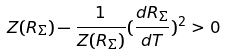<formula> <loc_0><loc_0><loc_500><loc_500>Z ( R _ { \Sigma } ) - \frac { 1 } { Z ( R _ { \Sigma } ) } ( \frac { d R _ { \Sigma } } { d T } ) ^ { 2 } > 0</formula> 